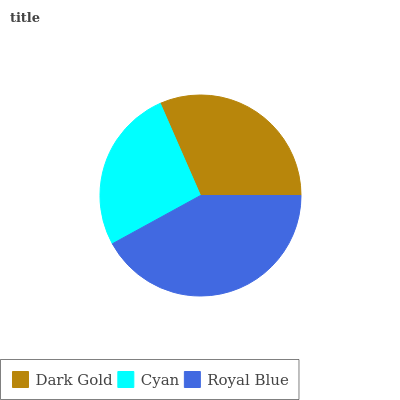Is Cyan the minimum?
Answer yes or no. Yes. Is Royal Blue the maximum?
Answer yes or no. Yes. Is Royal Blue the minimum?
Answer yes or no. No. Is Cyan the maximum?
Answer yes or no. No. Is Royal Blue greater than Cyan?
Answer yes or no. Yes. Is Cyan less than Royal Blue?
Answer yes or no. Yes. Is Cyan greater than Royal Blue?
Answer yes or no. No. Is Royal Blue less than Cyan?
Answer yes or no. No. Is Dark Gold the high median?
Answer yes or no. Yes. Is Dark Gold the low median?
Answer yes or no. Yes. Is Royal Blue the high median?
Answer yes or no. No. Is Cyan the low median?
Answer yes or no. No. 